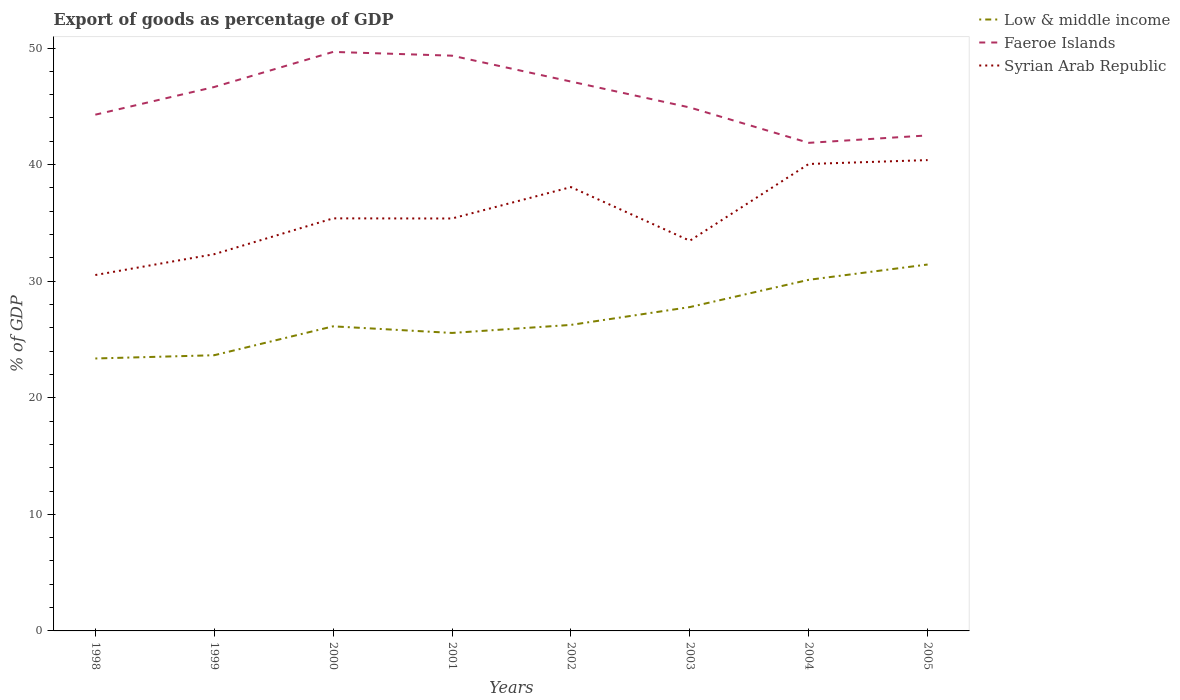How many different coloured lines are there?
Make the answer very short. 3. Across all years, what is the maximum export of goods as percentage of GDP in Faeroe Islands?
Give a very brief answer. 41.87. In which year was the export of goods as percentage of GDP in Syrian Arab Republic maximum?
Provide a short and direct response. 1998. What is the total export of goods as percentage of GDP in Low & middle income in the graph?
Provide a short and direct response. -7.78. What is the difference between the highest and the second highest export of goods as percentage of GDP in Syrian Arab Republic?
Keep it short and to the point. 9.86. Is the export of goods as percentage of GDP in Faeroe Islands strictly greater than the export of goods as percentage of GDP in Low & middle income over the years?
Offer a terse response. No. Are the values on the major ticks of Y-axis written in scientific E-notation?
Your answer should be very brief. No. Does the graph contain any zero values?
Give a very brief answer. No. Does the graph contain grids?
Your answer should be compact. No. What is the title of the graph?
Your answer should be compact. Export of goods as percentage of GDP. What is the label or title of the X-axis?
Provide a short and direct response. Years. What is the label or title of the Y-axis?
Offer a terse response. % of GDP. What is the % of GDP in Low & middle income in 1998?
Your response must be concise. 23.37. What is the % of GDP in Faeroe Islands in 1998?
Offer a terse response. 44.28. What is the % of GDP of Syrian Arab Republic in 1998?
Your answer should be very brief. 30.53. What is the % of GDP of Low & middle income in 1999?
Your answer should be compact. 23.65. What is the % of GDP of Faeroe Islands in 1999?
Offer a terse response. 46.66. What is the % of GDP of Syrian Arab Republic in 1999?
Provide a short and direct response. 32.32. What is the % of GDP in Low & middle income in 2000?
Keep it short and to the point. 26.13. What is the % of GDP in Faeroe Islands in 2000?
Keep it short and to the point. 49.67. What is the % of GDP of Syrian Arab Republic in 2000?
Ensure brevity in your answer.  35.39. What is the % of GDP in Low & middle income in 2001?
Provide a succinct answer. 25.56. What is the % of GDP in Faeroe Islands in 2001?
Offer a terse response. 49.34. What is the % of GDP in Syrian Arab Republic in 2001?
Ensure brevity in your answer.  35.38. What is the % of GDP of Low & middle income in 2002?
Offer a terse response. 26.25. What is the % of GDP in Faeroe Islands in 2002?
Provide a succinct answer. 47.12. What is the % of GDP in Syrian Arab Republic in 2002?
Keep it short and to the point. 38.07. What is the % of GDP in Low & middle income in 2003?
Offer a very short reply. 27.78. What is the % of GDP in Faeroe Islands in 2003?
Your response must be concise. 44.9. What is the % of GDP in Syrian Arab Republic in 2003?
Your answer should be very brief. 33.47. What is the % of GDP in Low & middle income in 2004?
Provide a succinct answer. 30.12. What is the % of GDP in Faeroe Islands in 2004?
Ensure brevity in your answer.  41.87. What is the % of GDP of Syrian Arab Republic in 2004?
Your response must be concise. 40.05. What is the % of GDP in Low & middle income in 2005?
Provide a short and direct response. 31.43. What is the % of GDP in Faeroe Islands in 2005?
Give a very brief answer. 42.5. What is the % of GDP of Syrian Arab Republic in 2005?
Your answer should be compact. 40.39. Across all years, what is the maximum % of GDP in Low & middle income?
Provide a succinct answer. 31.43. Across all years, what is the maximum % of GDP in Faeroe Islands?
Keep it short and to the point. 49.67. Across all years, what is the maximum % of GDP of Syrian Arab Republic?
Give a very brief answer. 40.39. Across all years, what is the minimum % of GDP in Low & middle income?
Make the answer very short. 23.37. Across all years, what is the minimum % of GDP of Faeroe Islands?
Keep it short and to the point. 41.87. Across all years, what is the minimum % of GDP in Syrian Arab Republic?
Give a very brief answer. 30.53. What is the total % of GDP of Low & middle income in the graph?
Ensure brevity in your answer.  214.29. What is the total % of GDP in Faeroe Islands in the graph?
Your response must be concise. 366.35. What is the total % of GDP of Syrian Arab Republic in the graph?
Your answer should be very brief. 285.6. What is the difference between the % of GDP in Low & middle income in 1998 and that in 1999?
Provide a short and direct response. -0.28. What is the difference between the % of GDP of Faeroe Islands in 1998 and that in 1999?
Offer a very short reply. -2.37. What is the difference between the % of GDP in Syrian Arab Republic in 1998 and that in 1999?
Provide a succinct answer. -1.79. What is the difference between the % of GDP of Low & middle income in 1998 and that in 2000?
Provide a succinct answer. -2.76. What is the difference between the % of GDP of Faeroe Islands in 1998 and that in 2000?
Offer a very short reply. -5.38. What is the difference between the % of GDP of Syrian Arab Republic in 1998 and that in 2000?
Keep it short and to the point. -4.86. What is the difference between the % of GDP in Low & middle income in 1998 and that in 2001?
Provide a succinct answer. -2.19. What is the difference between the % of GDP of Faeroe Islands in 1998 and that in 2001?
Ensure brevity in your answer.  -5.06. What is the difference between the % of GDP in Syrian Arab Republic in 1998 and that in 2001?
Keep it short and to the point. -4.85. What is the difference between the % of GDP of Low & middle income in 1998 and that in 2002?
Keep it short and to the point. -2.88. What is the difference between the % of GDP in Faeroe Islands in 1998 and that in 2002?
Your response must be concise. -2.84. What is the difference between the % of GDP of Syrian Arab Republic in 1998 and that in 2002?
Provide a succinct answer. -7.54. What is the difference between the % of GDP in Low & middle income in 1998 and that in 2003?
Make the answer very short. -4.41. What is the difference between the % of GDP of Faeroe Islands in 1998 and that in 2003?
Keep it short and to the point. -0.62. What is the difference between the % of GDP in Syrian Arab Republic in 1998 and that in 2003?
Your answer should be compact. -2.94. What is the difference between the % of GDP of Low & middle income in 1998 and that in 2004?
Your response must be concise. -6.75. What is the difference between the % of GDP of Faeroe Islands in 1998 and that in 2004?
Provide a succinct answer. 2.42. What is the difference between the % of GDP of Syrian Arab Republic in 1998 and that in 2004?
Provide a succinct answer. -9.53. What is the difference between the % of GDP in Low & middle income in 1998 and that in 2005?
Provide a short and direct response. -8.06. What is the difference between the % of GDP in Faeroe Islands in 1998 and that in 2005?
Your response must be concise. 1.78. What is the difference between the % of GDP of Syrian Arab Republic in 1998 and that in 2005?
Offer a terse response. -9.86. What is the difference between the % of GDP in Low & middle income in 1999 and that in 2000?
Offer a terse response. -2.48. What is the difference between the % of GDP of Faeroe Islands in 1999 and that in 2000?
Make the answer very short. -3.01. What is the difference between the % of GDP in Syrian Arab Republic in 1999 and that in 2000?
Offer a very short reply. -3.07. What is the difference between the % of GDP in Low & middle income in 1999 and that in 2001?
Your response must be concise. -1.91. What is the difference between the % of GDP in Faeroe Islands in 1999 and that in 2001?
Your answer should be very brief. -2.69. What is the difference between the % of GDP in Syrian Arab Republic in 1999 and that in 2001?
Your response must be concise. -3.06. What is the difference between the % of GDP in Low & middle income in 1999 and that in 2002?
Provide a succinct answer. -2.6. What is the difference between the % of GDP of Faeroe Islands in 1999 and that in 2002?
Offer a very short reply. -0.47. What is the difference between the % of GDP in Syrian Arab Republic in 1999 and that in 2002?
Offer a very short reply. -5.76. What is the difference between the % of GDP in Low & middle income in 1999 and that in 2003?
Your response must be concise. -4.13. What is the difference between the % of GDP of Faeroe Islands in 1999 and that in 2003?
Provide a succinct answer. 1.76. What is the difference between the % of GDP of Syrian Arab Republic in 1999 and that in 2003?
Offer a very short reply. -1.15. What is the difference between the % of GDP in Low & middle income in 1999 and that in 2004?
Give a very brief answer. -6.47. What is the difference between the % of GDP of Faeroe Islands in 1999 and that in 2004?
Your response must be concise. 4.79. What is the difference between the % of GDP in Syrian Arab Republic in 1999 and that in 2004?
Your response must be concise. -7.74. What is the difference between the % of GDP of Low & middle income in 1999 and that in 2005?
Provide a short and direct response. -7.78. What is the difference between the % of GDP of Faeroe Islands in 1999 and that in 2005?
Your response must be concise. 4.15. What is the difference between the % of GDP in Syrian Arab Republic in 1999 and that in 2005?
Provide a short and direct response. -8.07. What is the difference between the % of GDP of Low & middle income in 2000 and that in 2001?
Offer a terse response. 0.57. What is the difference between the % of GDP in Faeroe Islands in 2000 and that in 2001?
Provide a short and direct response. 0.32. What is the difference between the % of GDP in Syrian Arab Republic in 2000 and that in 2001?
Provide a succinct answer. 0.01. What is the difference between the % of GDP in Low & middle income in 2000 and that in 2002?
Make the answer very short. -0.12. What is the difference between the % of GDP in Faeroe Islands in 2000 and that in 2002?
Your answer should be very brief. 2.54. What is the difference between the % of GDP of Syrian Arab Republic in 2000 and that in 2002?
Your answer should be very brief. -2.68. What is the difference between the % of GDP in Low & middle income in 2000 and that in 2003?
Provide a succinct answer. -1.65. What is the difference between the % of GDP of Faeroe Islands in 2000 and that in 2003?
Provide a short and direct response. 4.77. What is the difference between the % of GDP in Syrian Arab Republic in 2000 and that in 2003?
Give a very brief answer. 1.92. What is the difference between the % of GDP in Low & middle income in 2000 and that in 2004?
Your answer should be compact. -3.99. What is the difference between the % of GDP of Faeroe Islands in 2000 and that in 2004?
Keep it short and to the point. 7.8. What is the difference between the % of GDP of Syrian Arab Republic in 2000 and that in 2004?
Provide a succinct answer. -4.66. What is the difference between the % of GDP in Low & middle income in 2000 and that in 2005?
Keep it short and to the point. -5.3. What is the difference between the % of GDP in Faeroe Islands in 2000 and that in 2005?
Your response must be concise. 7.16. What is the difference between the % of GDP of Syrian Arab Republic in 2000 and that in 2005?
Your response must be concise. -5. What is the difference between the % of GDP of Low & middle income in 2001 and that in 2002?
Your answer should be very brief. -0.69. What is the difference between the % of GDP in Faeroe Islands in 2001 and that in 2002?
Your response must be concise. 2.22. What is the difference between the % of GDP of Syrian Arab Republic in 2001 and that in 2002?
Keep it short and to the point. -2.69. What is the difference between the % of GDP of Low & middle income in 2001 and that in 2003?
Ensure brevity in your answer.  -2.22. What is the difference between the % of GDP in Faeroe Islands in 2001 and that in 2003?
Provide a succinct answer. 4.44. What is the difference between the % of GDP of Syrian Arab Republic in 2001 and that in 2003?
Provide a succinct answer. 1.91. What is the difference between the % of GDP of Low & middle income in 2001 and that in 2004?
Make the answer very short. -4.56. What is the difference between the % of GDP of Faeroe Islands in 2001 and that in 2004?
Make the answer very short. 7.48. What is the difference between the % of GDP of Syrian Arab Republic in 2001 and that in 2004?
Provide a short and direct response. -4.68. What is the difference between the % of GDP of Low & middle income in 2001 and that in 2005?
Keep it short and to the point. -5.87. What is the difference between the % of GDP of Faeroe Islands in 2001 and that in 2005?
Your response must be concise. 6.84. What is the difference between the % of GDP in Syrian Arab Republic in 2001 and that in 2005?
Your answer should be very brief. -5.01. What is the difference between the % of GDP in Low & middle income in 2002 and that in 2003?
Your answer should be compact. -1.53. What is the difference between the % of GDP in Faeroe Islands in 2002 and that in 2003?
Your answer should be compact. 2.22. What is the difference between the % of GDP in Syrian Arab Republic in 2002 and that in 2003?
Give a very brief answer. 4.6. What is the difference between the % of GDP in Low & middle income in 2002 and that in 2004?
Your response must be concise. -3.87. What is the difference between the % of GDP of Faeroe Islands in 2002 and that in 2004?
Provide a short and direct response. 5.26. What is the difference between the % of GDP of Syrian Arab Republic in 2002 and that in 2004?
Your answer should be very brief. -1.98. What is the difference between the % of GDP in Low & middle income in 2002 and that in 2005?
Provide a short and direct response. -5.18. What is the difference between the % of GDP of Faeroe Islands in 2002 and that in 2005?
Your answer should be compact. 4.62. What is the difference between the % of GDP in Syrian Arab Republic in 2002 and that in 2005?
Your answer should be very brief. -2.32. What is the difference between the % of GDP of Low & middle income in 2003 and that in 2004?
Provide a succinct answer. -2.34. What is the difference between the % of GDP in Faeroe Islands in 2003 and that in 2004?
Offer a very short reply. 3.03. What is the difference between the % of GDP of Syrian Arab Republic in 2003 and that in 2004?
Keep it short and to the point. -6.58. What is the difference between the % of GDP of Low & middle income in 2003 and that in 2005?
Offer a very short reply. -3.65. What is the difference between the % of GDP in Faeroe Islands in 2003 and that in 2005?
Provide a short and direct response. 2.4. What is the difference between the % of GDP of Syrian Arab Republic in 2003 and that in 2005?
Provide a succinct answer. -6.92. What is the difference between the % of GDP in Low & middle income in 2004 and that in 2005?
Your answer should be very brief. -1.31. What is the difference between the % of GDP of Faeroe Islands in 2004 and that in 2005?
Your answer should be compact. -0.64. What is the difference between the % of GDP in Syrian Arab Republic in 2004 and that in 2005?
Offer a terse response. -0.33. What is the difference between the % of GDP of Low & middle income in 1998 and the % of GDP of Faeroe Islands in 1999?
Provide a succinct answer. -23.29. What is the difference between the % of GDP in Low & middle income in 1998 and the % of GDP in Syrian Arab Republic in 1999?
Offer a very short reply. -8.95. What is the difference between the % of GDP of Faeroe Islands in 1998 and the % of GDP of Syrian Arab Republic in 1999?
Your response must be concise. 11.97. What is the difference between the % of GDP in Low & middle income in 1998 and the % of GDP in Faeroe Islands in 2000?
Provide a short and direct response. -26.3. What is the difference between the % of GDP in Low & middle income in 1998 and the % of GDP in Syrian Arab Republic in 2000?
Offer a terse response. -12.02. What is the difference between the % of GDP of Faeroe Islands in 1998 and the % of GDP of Syrian Arab Republic in 2000?
Offer a very short reply. 8.89. What is the difference between the % of GDP of Low & middle income in 1998 and the % of GDP of Faeroe Islands in 2001?
Keep it short and to the point. -25.97. What is the difference between the % of GDP of Low & middle income in 1998 and the % of GDP of Syrian Arab Republic in 2001?
Provide a succinct answer. -12.01. What is the difference between the % of GDP in Faeroe Islands in 1998 and the % of GDP in Syrian Arab Republic in 2001?
Offer a terse response. 8.91. What is the difference between the % of GDP in Low & middle income in 1998 and the % of GDP in Faeroe Islands in 2002?
Offer a terse response. -23.75. What is the difference between the % of GDP in Low & middle income in 1998 and the % of GDP in Syrian Arab Republic in 2002?
Give a very brief answer. -14.7. What is the difference between the % of GDP in Faeroe Islands in 1998 and the % of GDP in Syrian Arab Republic in 2002?
Offer a very short reply. 6.21. What is the difference between the % of GDP in Low & middle income in 1998 and the % of GDP in Faeroe Islands in 2003?
Give a very brief answer. -21.53. What is the difference between the % of GDP of Low & middle income in 1998 and the % of GDP of Syrian Arab Republic in 2003?
Offer a very short reply. -10.1. What is the difference between the % of GDP in Faeroe Islands in 1998 and the % of GDP in Syrian Arab Republic in 2003?
Make the answer very short. 10.81. What is the difference between the % of GDP of Low & middle income in 1998 and the % of GDP of Faeroe Islands in 2004?
Your answer should be compact. -18.5. What is the difference between the % of GDP of Low & middle income in 1998 and the % of GDP of Syrian Arab Republic in 2004?
Ensure brevity in your answer.  -16.68. What is the difference between the % of GDP of Faeroe Islands in 1998 and the % of GDP of Syrian Arab Republic in 2004?
Ensure brevity in your answer.  4.23. What is the difference between the % of GDP in Low & middle income in 1998 and the % of GDP in Faeroe Islands in 2005?
Provide a succinct answer. -19.14. What is the difference between the % of GDP of Low & middle income in 1998 and the % of GDP of Syrian Arab Republic in 2005?
Provide a short and direct response. -17.02. What is the difference between the % of GDP of Faeroe Islands in 1998 and the % of GDP of Syrian Arab Republic in 2005?
Keep it short and to the point. 3.9. What is the difference between the % of GDP of Low & middle income in 1999 and the % of GDP of Faeroe Islands in 2000?
Offer a very short reply. -26.02. What is the difference between the % of GDP of Low & middle income in 1999 and the % of GDP of Syrian Arab Republic in 2000?
Give a very brief answer. -11.74. What is the difference between the % of GDP of Faeroe Islands in 1999 and the % of GDP of Syrian Arab Republic in 2000?
Your answer should be compact. 11.27. What is the difference between the % of GDP of Low & middle income in 1999 and the % of GDP of Faeroe Islands in 2001?
Make the answer very short. -25.7. What is the difference between the % of GDP of Low & middle income in 1999 and the % of GDP of Syrian Arab Republic in 2001?
Your answer should be very brief. -11.73. What is the difference between the % of GDP of Faeroe Islands in 1999 and the % of GDP of Syrian Arab Republic in 2001?
Keep it short and to the point. 11.28. What is the difference between the % of GDP in Low & middle income in 1999 and the % of GDP in Faeroe Islands in 2002?
Ensure brevity in your answer.  -23.47. What is the difference between the % of GDP of Low & middle income in 1999 and the % of GDP of Syrian Arab Republic in 2002?
Your answer should be compact. -14.42. What is the difference between the % of GDP in Faeroe Islands in 1999 and the % of GDP in Syrian Arab Republic in 2002?
Make the answer very short. 8.59. What is the difference between the % of GDP in Low & middle income in 1999 and the % of GDP in Faeroe Islands in 2003?
Give a very brief answer. -21.25. What is the difference between the % of GDP in Low & middle income in 1999 and the % of GDP in Syrian Arab Republic in 2003?
Offer a very short reply. -9.82. What is the difference between the % of GDP of Faeroe Islands in 1999 and the % of GDP of Syrian Arab Republic in 2003?
Provide a short and direct response. 13.19. What is the difference between the % of GDP in Low & middle income in 1999 and the % of GDP in Faeroe Islands in 2004?
Ensure brevity in your answer.  -18.22. What is the difference between the % of GDP in Low & middle income in 1999 and the % of GDP in Syrian Arab Republic in 2004?
Offer a very short reply. -16.41. What is the difference between the % of GDP of Faeroe Islands in 1999 and the % of GDP of Syrian Arab Republic in 2004?
Make the answer very short. 6.6. What is the difference between the % of GDP of Low & middle income in 1999 and the % of GDP of Faeroe Islands in 2005?
Ensure brevity in your answer.  -18.86. What is the difference between the % of GDP in Low & middle income in 1999 and the % of GDP in Syrian Arab Republic in 2005?
Give a very brief answer. -16.74. What is the difference between the % of GDP in Faeroe Islands in 1999 and the % of GDP in Syrian Arab Republic in 2005?
Your answer should be compact. 6.27. What is the difference between the % of GDP of Low & middle income in 2000 and the % of GDP of Faeroe Islands in 2001?
Keep it short and to the point. -23.22. What is the difference between the % of GDP in Low & middle income in 2000 and the % of GDP in Syrian Arab Republic in 2001?
Offer a terse response. -9.25. What is the difference between the % of GDP of Faeroe Islands in 2000 and the % of GDP of Syrian Arab Republic in 2001?
Your response must be concise. 14.29. What is the difference between the % of GDP in Low & middle income in 2000 and the % of GDP in Faeroe Islands in 2002?
Your answer should be very brief. -21. What is the difference between the % of GDP of Low & middle income in 2000 and the % of GDP of Syrian Arab Republic in 2002?
Make the answer very short. -11.94. What is the difference between the % of GDP in Faeroe Islands in 2000 and the % of GDP in Syrian Arab Republic in 2002?
Provide a succinct answer. 11.6. What is the difference between the % of GDP of Low & middle income in 2000 and the % of GDP of Faeroe Islands in 2003?
Your answer should be compact. -18.77. What is the difference between the % of GDP in Low & middle income in 2000 and the % of GDP in Syrian Arab Republic in 2003?
Offer a very short reply. -7.34. What is the difference between the % of GDP in Faeroe Islands in 2000 and the % of GDP in Syrian Arab Republic in 2003?
Provide a short and direct response. 16.2. What is the difference between the % of GDP in Low & middle income in 2000 and the % of GDP in Faeroe Islands in 2004?
Make the answer very short. -15.74. What is the difference between the % of GDP in Low & middle income in 2000 and the % of GDP in Syrian Arab Republic in 2004?
Give a very brief answer. -13.93. What is the difference between the % of GDP in Faeroe Islands in 2000 and the % of GDP in Syrian Arab Republic in 2004?
Keep it short and to the point. 9.61. What is the difference between the % of GDP in Low & middle income in 2000 and the % of GDP in Faeroe Islands in 2005?
Provide a succinct answer. -16.38. What is the difference between the % of GDP in Low & middle income in 2000 and the % of GDP in Syrian Arab Republic in 2005?
Provide a short and direct response. -14.26. What is the difference between the % of GDP of Faeroe Islands in 2000 and the % of GDP of Syrian Arab Republic in 2005?
Your answer should be very brief. 9.28. What is the difference between the % of GDP in Low & middle income in 2001 and the % of GDP in Faeroe Islands in 2002?
Make the answer very short. -21.56. What is the difference between the % of GDP of Low & middle income in 2001 and the % of GDP of Syrian Arab Republic in 2002?
Keep it short and to the point. -12.51. What is the difference between the % of GDP in Faeroe Islands in 2001 and the % of GDP in Syrian Arab Republic in 2002?
Offer a terse response. 11.27. What is the difference between the % of GDP in Low & middle income in 2001 and the % of GDP in Faeroe Islands in 2003?
Keep it short and to the point. -19.34. What is the difference between the % of GDP in Low & middle income in 2001 and the % of GDP in Syrian Arab Republic in 2003?
Provide a succinct answer. -7.91. What is the difference between the % of GDP in Faeroe Islands in 2001 and the % of GDP in Syrian Arab Republic in 2003?
Give a very brief answer. 15.87. What is the difference between the % of GDP in Low & middle income in 2001 and the % of GDP in Faeroe Islands in 2004?
Offer a very short reply. -16.31. What is the difference between the % of GDP in Low & middle income in 2001 and the % of GDP in Syrian Arab Republic in 2004?
Provide a succinct answer. -14.49. What is the difference between the % of GDP in Faeroe Islands in 2001 and the % of GDP in Syrian Arab Republic in 2004?
Provide a succinct answer. 9.29. What is the difference between the % of GDP of Low & middle income in 2001 and the % of GDP of Faeroe Islands in 2005?
Give a very brief answer. -16.94. What is the difference between the % of GDP of Low & middle income in 2001 and the % of GDP of Syrian Arab Republic in 2005?
Your response must be concise. -14.83. What is the difference between the % of GDP of Faeroe Islands in 2001 and the % of GDP of Syrian Arab Republic in 2005?
Keep it short and to the point. 8.96. What is the difference between the % of GDP in Low & middle income in 2002 and the % of GDP in Faeroe Islands in 2003?
Ensure brevity in your answer.  -18.65. What is the difference between the % of GDP in Low & middle income in 2002 and the % of GDP in Syrian Arab Republic in 2003?
Make the answer very short. -7.22. What is the difference between the % of GDP in Faeroe Islands in 2002 and the % of GDP in Syrian Arab Republic in 2003?
Provide a short and direct response. 13.65. What is the difference between the % of GDP in Low & middle income in 2002 and the % of GDP in Faeroe Islands in 2004?
Give a very brief answer. -15.62. What is the difference between the % of GDP of Low & middle income in 2002 and the % of GDP of Syrian Arab Republic in 2004?
Make the answer very short. -13.8. What is the difference between the % of GDP of Faeroe Islands in 2002 and the % of GDP of Syrian Arab Republic in 2004?
Ensure brevity in your answer.  7.07. What is the difference between the % of GDP of Low & middle income in 2002 and the % of GDP of Faeroe Islands in 2005?
Offer a terse response. -16.25. What is the difference between the % of GDP of Low & middle income in 2002 and the % of GDP of Syrian Arab Republic in 2005?
Offer a very short reply. -14.14. What is the difference between the % of GDP of Faeroe Islands in 2002 and the % of GDP of Syrian Arab Republic in 2005?
Your response must be concise. 6.74. What is the difference between the % of GDP in Low & middle income in 2003 and the % of GDP in Faeroe Islands in 2004?
Keep it short and to the point. -14.09. What is the difference between the % of GDP in Low & middle income in 2003 and the % of GDP in Syrian Arab Republic in 2004?
Offer a terse response. -12.28. What is the difference between the % of GDP in Faeroe Islands in 2003 and the % of GDP in Syrian Arab Republic in 2004?
Give a very brief answer. 4.85. What is the difference between the % of GDP in Low & middle income in 2003 and the % of GDP in Faeroe Islands in 2005?
Offer a very short reply. -14.73. What is the difference between the % of GDP in Low & middle income in 2003 and the % of GDP in Syrian Arab Republic in 2005?
Make the answer very short. -12.61. What is the difference between the % of GDP of Faeroe Islands in 2003 and the % of GDP of Syrian Arab Republic in 2005?
Offer a very short reply. 4.51. What is the difference between the % of GDP of Low & middle income in 2004 and the % of GDP of Faeroe Islands in 2005?
Your answer should be compact. -12.39. What is the difference between the % of GDP of Low & middle income in 2004 and the % of GDP of Syrian Arab Republic in 2005?
Your response must be concise. -10.27. What is the difference between the % of GDP of Faeroe Islands in 2004 and the % of GDP of Syrian Arab Republic in 2005?
Keep it short and to the point. 1.48. What is the average % of GDP of Low & middle income per year?
Your answer should be very brief. 26.79. What is the average % of GDP of Faeroe Islands per year?
Make the answer very short. 45.79. What is the average % of GDP in Syrian Arab Republic per year?
Offer a very short reply. 35.7. In the year 1998, what is the difference between the % of GDP in Low & middle income and % of GDP in Faeroe Islands?
Give a very brief answer. -20.91. In the year 1998, what is the difference between the % of GDP of Low & middle income and % of GDP of Syrian Arab Republic?
Make the answer very short. -7.16. In the year 1998, what is the difference between the % of GDP of Faeroe Islands and % of GDP of Syrian Arab Republic?
Give a very brief answer. 13.75. In the year 1999, what is the difference between the % of GDP in Low & middle income and % of GDP in Faeroe Islands?
Your answer should be very brief. -23.01. In the year 1999, what is the difference between the % of GDP in Low & middle income and % of GDP in Syrian Arab Republic?
Offer a very short reply. -8.67. In the year 1999, what is the difference between the % of GDP in Faeroe Islands and % of GDP in Syrian Arab Republic?
Keep it short and to the point. 14.34. In the year 2000, what is the difference between the % of GDP of Low & middle income and % of GDP of Faeroe Islands?
Provide a short and direct response. -23.54. In the year 2000, what is the difference between the % of GDP of Low & middle income and % of GDP of Syrian Arab Republic?
Offer a terse response. -9.26. In the year 2000, what is the difference between the % of GDP of Faeroe Islands and % of GDP of Syrian Arab Republic?
Keep it short and to the point. 14.28. In the year 2001, what is the difference between the % of GDP of Low & middle income and % of GDP of Faeroe Islands?
Make the answer very short. -23.78. In the year 2001, what is the difference between the % of GDP of Low & middle income and % of GDP of Syrian Arab Republic?
Ensure brevity in your answer.  -9.82. In the year 2001, what is the difference between the % of GDP in Faeroe Islands and % of GDP in Syrian Arab Republic?
Keep it short and to the point. 13.97. In the year 2002, what is the difference between the % of GDP of Low & middle income and % of GDP of Faeroe Islands?
Ensure brevity in your answer.  -20.87. In the year 2002, what is the difference between the % of GDP in Low & middle income and % of GDP in Syrian Arab Republic?
Give a very brief answer. -11.82. In the year 2002, what is the difference between the % of GDP of Faeroe Islands and % of GDP of Syrian Arab Republic?
Your answer should be compact. 9.05. In the year 2003, what is the difference between the % of GDP of Low & middle income and % of GDP of Faeroe Islands?
Give a very brief answer. -17.12. In the year 2003, what is the difference between the % of GDP in Low & middle income and % of GDP in Syrian Arab Republic?
Offer a very short reply. -5.69. In the year 2003, what is the difference between the % of GDP of Faeroe Islands and % of GDP of Syrian Arab Republic?
Give a very brief answer. 11.43. In the year 2004, what is the difference between the % of GDP of Low & middle income and % of GDP of Faeroe Islands?
Offer a very short reply. -11.75. In the year 2004, what is the difference between the % of GDP in Low & middle income and % of GDP in Syrian Arab Republic?
Provide a short and direct response. -9.94. In the year 2004, what is the difference between the % of GDP of Faeroe Islands and % of GDP of Syrian Arab Republic?
Provide a short and direct response. 1.81. In the year 2005, what is the difference between the % of GDP in Low & middle income and % of GDP in Faeroe Islands?
Your response must be concise. -11.07. In the year 2005, what is the difference between the % of GDP in Low & middle income and % of GDP in Syrian Arab Republic?
Provide a succinct answer. -8.96. In the year 2005, what is the difference between the % of GDP in Faeroe Islands and % of GDP in Syrian Arab Republic?
Ensure brevity in your answer.  2.12. What is the ratio of the % of GDP in Faeroe Islands in 1998 to that in 1999?
Give a very brief answer. 0.95. What is the ratio of the % of GDP of Syrian Arab Republic in 1998 to that in 1999?
Make the answer very short. 0.94. What is the ratio of the % of GDP of Low & middle income in 1998 to that in 2000?
Your answer should be very brief. 0.89. What is the ratio of the % of GDP in Faeroe Islands in 1998 to that in 2000?
Offer a very short reply. 0.89. What is the ratio of the % of GDP of Syrian Arab Republic in 1998 to that in 2000?
Give a very brief answer. 0.86. What is the ratio of the % of GDP of Low & middle income in 1998 to that in 2001?
Keep it short and to the point. 0.91. What is the ratio of the % of GDP in Faeroe Islands in 1998 to that in 2001?
Offer a terse response. 0.9. What is the ratio of the % of GDP in Syrian Arab Republic in 1998 to that in 2001?
Your response must be concise. 0.86. What is the ratio of the % of GDP of Low & middle income in 1998 to that in 2002?
Your answer should be very brief. 0.89. What is the ratio of the % of GDP of Faeroe Islands in 1998 to that in 2002?
Your answer should be very brief. 0.94. What is the ratio of the % of GDP of Syrian Arab Republic in 1998 to that in 2002?
Provide a short and direct response. 0.8. What is the ratio of the % of GDP of Low & middle income in 1998 to that in 2003?
Give a very brief answer. 0.84. What is the ratio of the % of GDP in Faeroe Islands in 1998 to that in 2003?
Keep it short and to the point. 0.99. What is the ratio of the % of GDP in Syrian Arab Republic in 1998 to that in 2003?
Offer a terse response. 0.91. What is the ratio of the % of GDP of Low & middle income in 1998 to that in 2004?
Your answer should be very brief. 0.78. What is the ratio of the % of GDP in Faeroe Islands in 1998 to that in 2004?
Give a very brief answer. 1.06. What is the ratio of the % of GDP of Syrian Arab Republic in 1998 to that in 2004?
Ensure brevity in your answer.  0.76. What is the ratio of the % of GDP in Low & middle income in 1998 to that in 2005?
Give a very brief answer. 0.74. What is the ratio of the % of GDP in Faeroe Islands in 1998 to that in 2005?
Keep it short and to the point. 1.04. What is the ratio of the % of GDP in Syrian Arab Republic in 1998 to that in 2005?
Make the answer very short. 0.76. What is the ratio of the % of GDP in Low & middle income in 1999 to that in 2000?
Ensure brevity in your answer.  0.91. What is the ratio of the % of GDP of Faeroe Islands in 1999 to that in 2000?
Your answer should be very brief. 0.94. What is the ratio of the % of GDP in Syrian Arab Republic in 1999 to that in 2000?
Your answer should be compact. 0.91. What is the ratio of the % of GDP in Low & middle income in 1999 to that in 2001?
Provide a short and direct response. 0.93. What is the ratio of the % of GDP of Faeroe Islands in 1999 to that in 2001?
Keep it short and to the point. 0.95. What is the ratio of the % of GDP of Syrian Arab Republic in 1999 to that in 2001?
Your answer should be very brief. 0.91. What is the ratio of the % of GDP in Low & middle income in 1999 to that in 2002?
Make the answer very short. 0.9. What is the ratio of the % of GDP in Faeroe Islands in 1999 to that in 2002?
Offer a terse response. 0.99. What is the ratio of the % of GDP in Syrian Arab Republic in 1999 to that in 2002?
Provide a short and direct response. 0.85. What is the ratio of the % of GDP in Low & middle income in 1999 to that in 2003?
Keep it short and to the point. 0.85. What is the ratio of the % of GDP in Faeroe Islands in 1999 to that in 2003?
Provide a succinct answer. 1.04. What is the ratio of the % of GDP of Syrian Arab Republic in 1999 to that in 2003?
Keep it short and to the point. 0.97. What is the ratio of the % of GDP of Low & middle income in 1999 to that in 2004?
Ensure brevity in your answer.  0.79. What is the ratio of the % of GDP of Faeroe Islands in 1999 to that in 2004?
Your response must be concise. 1.11. What is the ratio of the % of GDP of Syrian Arab Republic in 1999 to that in 2004?
Your response must be concise. 0.81. What is the ratio of the % of GDP of Low & middle income in 1999 to that in 2005?
Your answer should be very brief. 0.75. What is the ratio of the % of GDP of Faeroe Islands in 1999 to that in 2005?
Your response must be concise. 1.1. What is the ratio of the % of GDP of Syrian Arab Republic in 1999 to that in 2005?
Ensure brevity in your answer.  0.8. What is the ratio of the % of GDP in Low & middle income in 2000 to that in 2001?
Provide a succinct answer. 1.02. What is the ratio of the % of GDP of Faeroe Islands in 2000 to that in 2001?
Offer a very short reply. 1.01. What is the ratio of the % of GDP in Syrian Arab Republic in 2000 to that in 2001?
Give a very brief answer. 1. What is the ratio of the % of GDP in Faeroe Islands in 2000 to that in 2002?
Your answer should be compact. 1.05. What is the ratio of the % of GDP of Syrian Arab Republic in 2000 to that in 2002?
Give a very brief answer. 0.93. What is the ratio of the % of GDP of Low & middle income in 2000 to that in 2003?
Give a very brief answer. 0.94. What is the ratio of the % of GDP of Faeroe Islands in 2000 to that in 2003?
Give a very brief answer. 1.11. What is the ratio of the % of GDP of Syrian Arab Republic in 2000 to that in 2003?
Provide a succinct answer. 1.06. What is the ratio of the % of GDP of Low & middle income in 2000 to that in 2004?
Your answer should be compact. 0.87. What is the ratio of the % of GDP of Faeroe Islands in 2000 to that in 2004?
Offer a very short reply. 1.19. What is the ratio of the % of GDP of Syrian Arab Republic in 2000 to that in 2004?
Keep it short and to the point. 0.88. What is the ratio of the % of GDP of Low & middle income in 2000 to that in 2005?
Give a very brief answer. 0.83. What is the ratio of the % of GDP in Faeroe Islands in 2000 to that in 2005?
Offer a terse response. 1.17. What is the ratio of the % of GDP of Syrian Arab Republic in 2000 to that in 2005?
Ensure brevity in your answer.  0.88. What is the ratio of the % of GDP of Low & middle income in 2001 to that in 2002?
Provide a succinct answer. 0.97. What is the ratio of the % of GDP in Faeroe Islands in 2001 to that in 2002?
Ensure brevity in your answer.  1.05. What is the ratio of the % of GDP in Syrian Arab Republic in 2001 to that in 2002?
Your answer should be very brief. 0.93. What is the ratio of the % of GDP in Low & middle income in 2001 to that in 2003?
Your answer should be very brief. 0.92. What is the ratio of the % of GDP in Faeroe Islands in 2001 to that in 2003?
Your response must be concise. 1.1. What is the ratio of the % of GDP of Syrian Arab Republic in 2001 to that in 2003?
Your response must be concise. 1.06. What is the ratio of the % of GDP in Low & middle income in 2001 to that in 2004?
Offer a very short reply. 0.85. What is the ratio of the % of GDP in Faeroe Islands in 2001 to that in 2004?
Offer a very short reply. 1.18. What is the ratio of the % of GDP in Syrian Arab Republic in 2001 to that in 2004?
Provide a short and direct response. 0.88. What is the ratio of the % of GDP in Low & middle income in 2001 to that in 2005?
Your response must be concise. 0.81. What is the ratio of the % of GDP of Faeroe Islands in 2001 to that in 2005?
Provide a succinct answer. 1.16. What is the ratio of the % of GDP of Syrian Arab Republic in 2001 to that in 2005?
Ensure brevity in your answer.  0.88. What is the ratio of the % of GDP in Low & middle income in 2002 to that in 2003?
Your answer should be compact. 0.94. What is the ratio of the % of GDP of Faeroe Islands in 2002 to that in 2003?
Your answer should be very brief. 1.05. What is the ratio of the % of GDP of Syrian Arab Republic in 2002 to that in 2003?
Your response must be concise. 1.14. What is the ratio of the % of GDP of Low & middle income in 2002 to that in 2004?
Offer a terse response. 0.87. What is the ratio of the % of GDP of Faeroe Islands in 2002 to that in 2004?
Your response must be concise. 1.13. What is the ratio of the % of GDP in Syrian Arab Republic in 2002 to that in 2004?
Your answer should be very brief. 0.95. What is the ratio of the % of GDP of Low & middle income in 2002 to that in 2005?
Make the answer very short. 0.84. What is the ratio of the % of GDP of Faeroe Islands in 2002 to that in 2005?
Offer a terse response. 1.11. What is the ratio of the % of GDP in Syrian Arab Republic in 2002 to that in 2005?
Offer a very short reply. 0.94. What is the ratio of the % of GDP of Low & middle income in 2003 to that in 2004?
Offer a terse response. 0.92. What is the ratio of the % of GDP of Faeroe Islands in 2003 to that in 2004?
Provide a succinct answer. 1.07. What is the ratio of the % of GDP of Syrian Arab Republic in 2003 to that in 2004?
Provide a succinct answer. 0.84. What is the ratio of the % of GDP of Low & middle income in 2003 to that in 2005?
Give a very brief answer. 0.88. What is the ratio of the % of GDP in Faeroe Islands in 2003 to that in 2005?
Keep it short and to the point. 1.06. What is the ratio of the % of GDP of Syrian Arab Republic in 2003 to that in 2005?
Your answer should be compact. 0.83. What is the ratio of the % of GDP in Faeroe Islands in 2004 to that in 2005?
Your answer should be very brief. 0.98. What is the difference between the highest and the second highest % of GDP in Low & middle income?
Provide a succinct answer. 1.31. What is the difference between the highest and the second highest % of GDP in Faeroe Islands?
Provide a short and direct response. 0.32. What is the difference between the highest and the second highest % of GDP in Syrian Arab Republic?
Make the answer very short. 0.33. What is the difference between the highest and the lowest % of GDP in Low & middle income?
Offer a terse response. 8.06. What is the difference between the highest and the lowest % of GDP in Faeroe Islands?
Your answer should be very brief. 7.8. What is the difference between the highest and the lowest % of GDP in Syrian Arab Republic?
Keep it short and to the point. 9.86. 